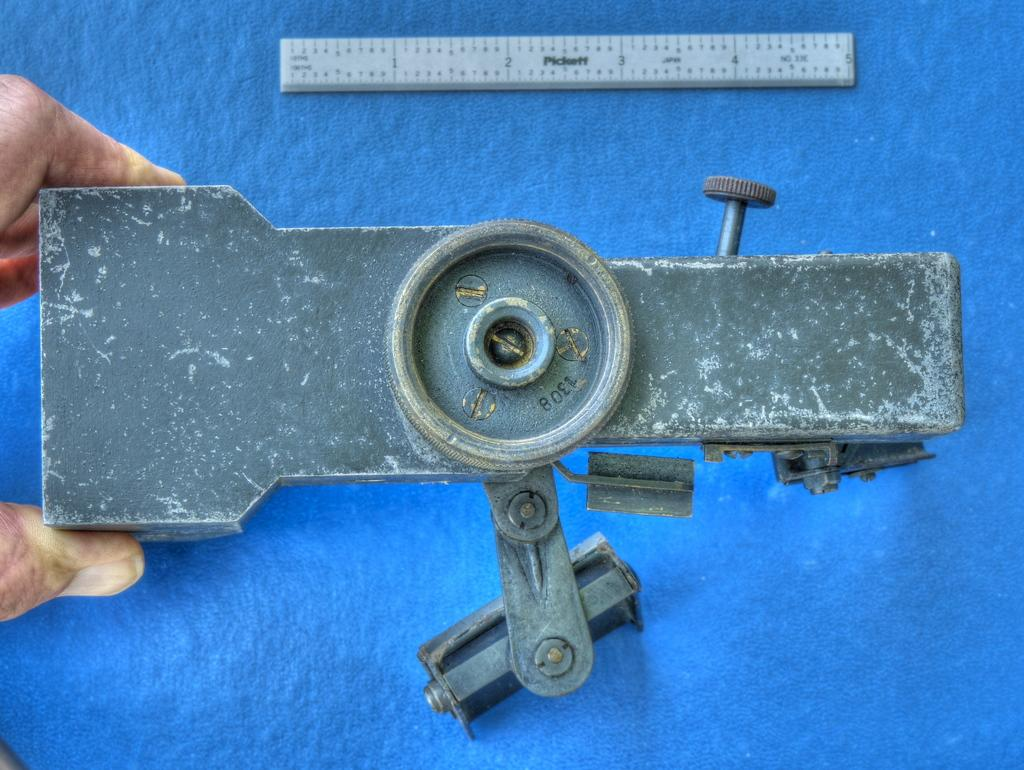Provide a one-sentence caption for the provided image. A person holding onto a metal item with a measurement device that goes 1 to 12. 